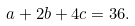<formula> <loc_0><loc_0><loc_500><loc_500>a + 2 b + 4 c = 3 6 .</formula> 